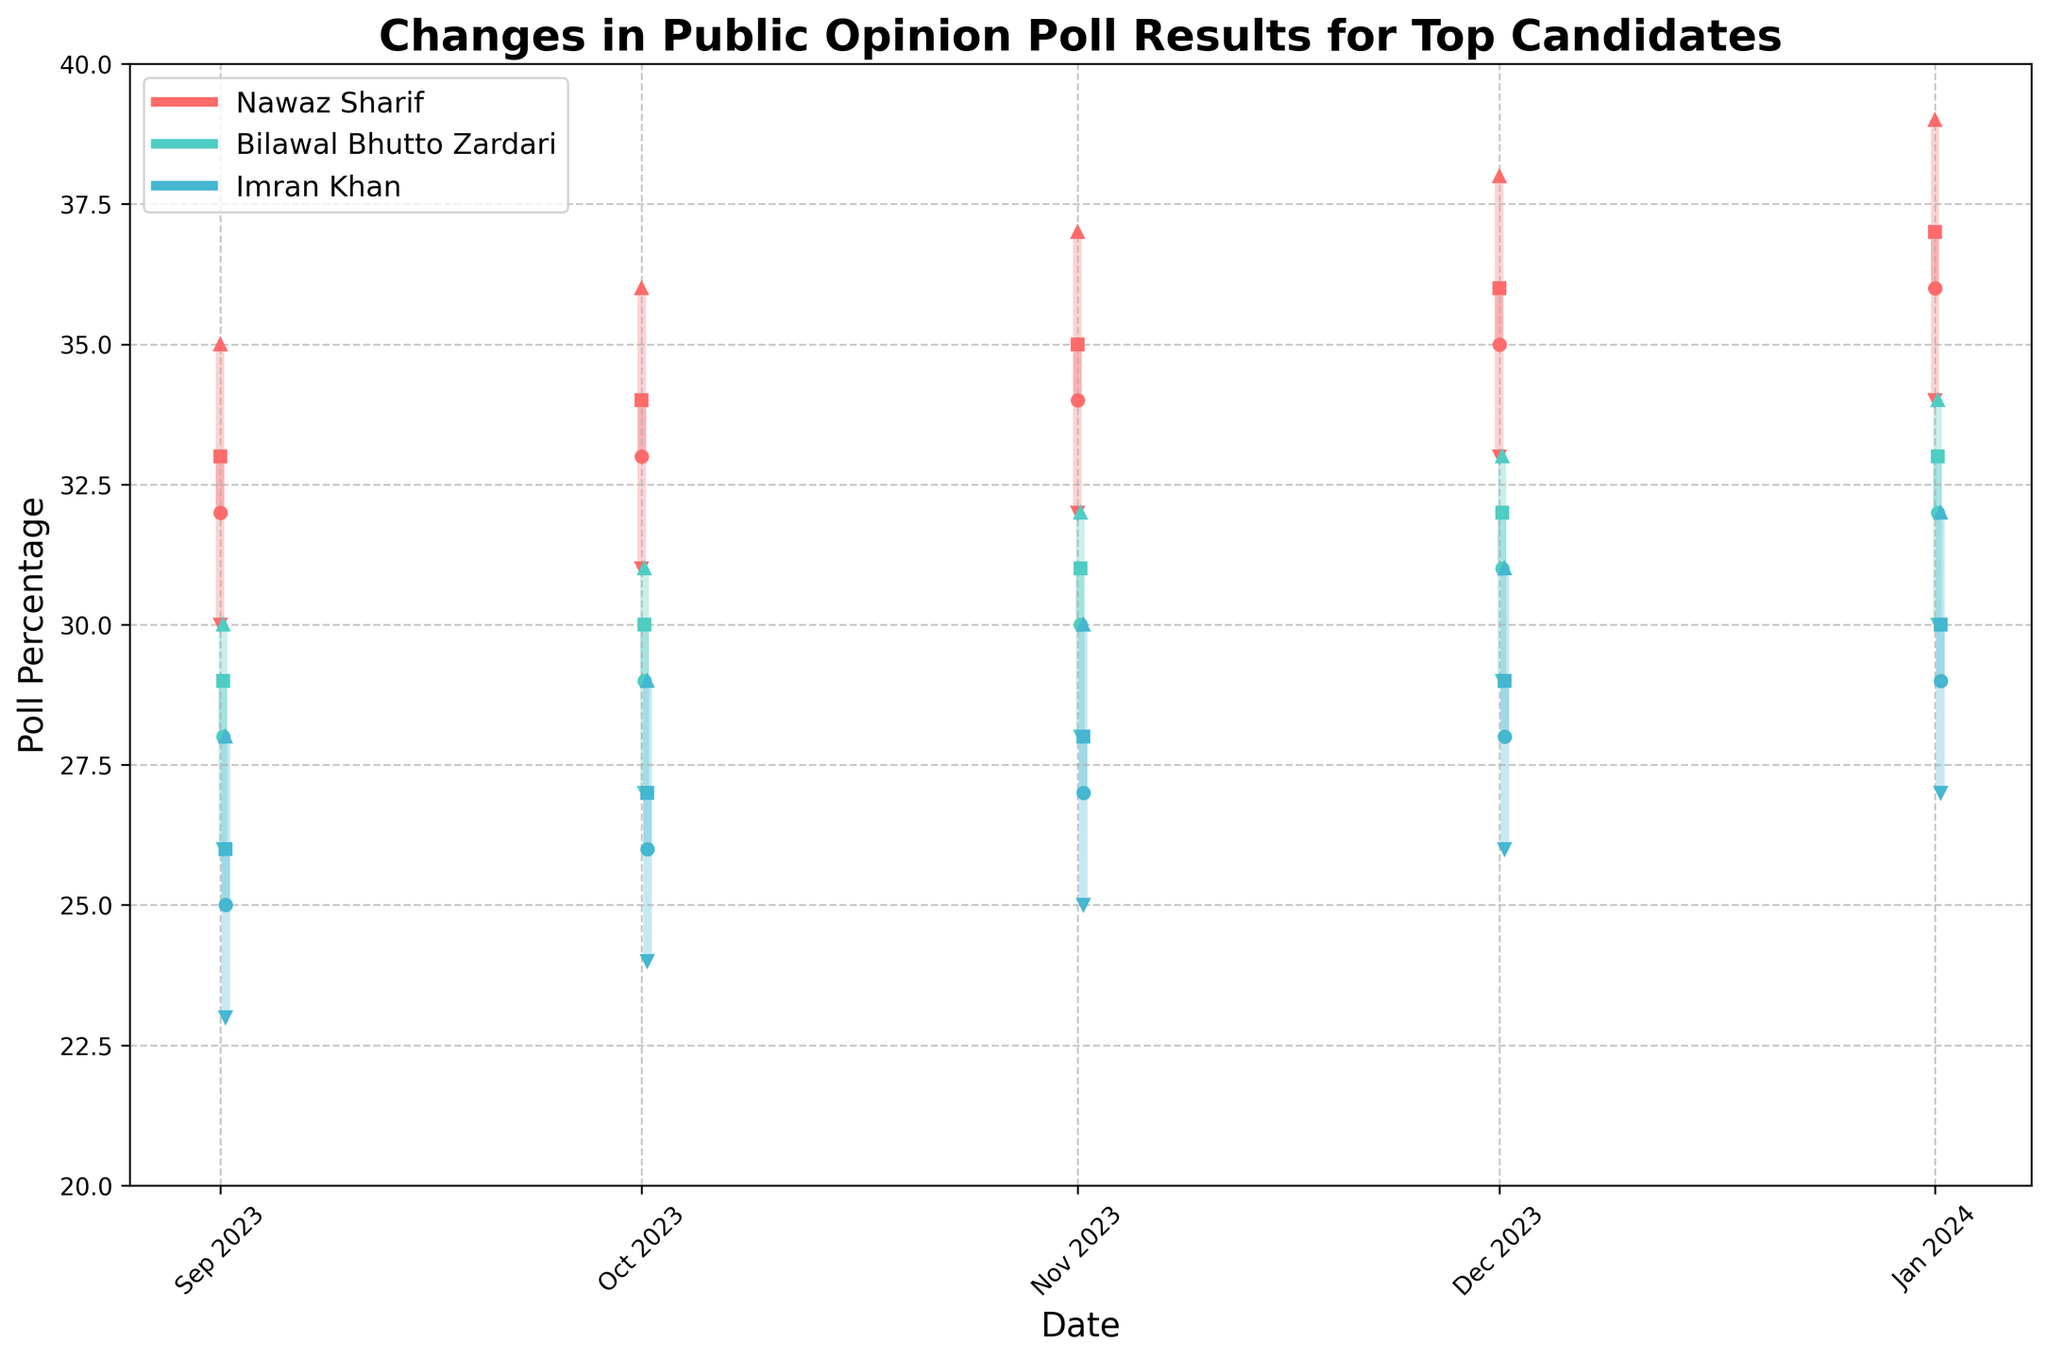What is the title of the figure? The title is located at the top of the figure, in a larger and bold font to distinguish it from the rest of the text. It indicates what the chart is about.
Answer: Changes in Public Opinion Poll Results for Top Candidates What are the colors associated with each candidate in the figure? The colors for each candidate can be identified by looking at the bars and lines in the figure and matching them to the legend.
Answer: Nawaz Sharif is red, Bilawal Bhutto Zardari is teal, Imran Khan is light blue How many data points are there for each candidate throughout the campaign? The data points correspond to the dates marked on the x-axis, with each candidate having one data point per month from September 2023 to January 2024.
Answer: 5 data points Which candidate had the highest closing value in January 2024? Look at the closing values (square markers) for each candidate in January 2024 and compare them.
Answer: Nawaz Sharif What was the lowest percentage that Bilawal Bhutto Zardari experienced during the campaign? Check the lowest values on the y-axis for Bilawal Bhutto Zardari represented by the downward triangle markers across all dates.
Answer: 26% Between which two consecutive months did Nawaz Sharif's closing percentage increase the most? Calculate the difference in the closing percentage for each consecutive pair of months for Nawaz Sharif and identify the largest increase.
Answer: December 2023 to January 2024 What is the average closing percentage of Imran Khan throughout the campaign? Sum the closing percentages for Imran Khan across all months and divide by the number of data points (5). (26 + 27 + 28 + 29 + 30) / 5 = 28
Answer: 28 Did any candidate's high percentage ever drop below the opening percentage of Imran Khan for that month? If so, which one and when? Compare the high percentages of each candidate across all months with the opening percentages of Imran Khan.
Answer: Yes, Bilawal Bhutto Zardari in September 2023 Which candidate showed the most stable polling trend in terms of the smallest range between high and low values? Calculate the range from high to low values for each candidate across all dates and identify the one with the smallest ranges.
Answer: Bilawal Bhutto Zardari How did Imran Khan's poll percentages change from September 2023 to January 2024 in terms of opening and closing values? Identify and compare the opening and closing percentages for Imran Khan in September 2023 and January 2024. The opening value in September 2023 was 25%, and in January 2024 it was 29%, an increase of 4%. The closing value in September 2023 was 26%, and in January 2024 it was 30%, an increase of 4%.
Answer: Increased by 4% for both opening and closing What was the trend of Nawaz Sharif's polling percentage from September 2023 to January 2024? Analyze the trend by observing the consecutive values of Nawaz Sharif's poll percentages and describe whether they increased, decreased, or stayed the same. September: Open 32, Close 33. October: Open 33, Close 34. November: Open 34, Close 35. December: Open 35, Close 36. January: Open 36, Close 37. As we can see, Nawaz Sharif's polling percentages showed a consistent rising trend each month.
Answer: Increasing trend 